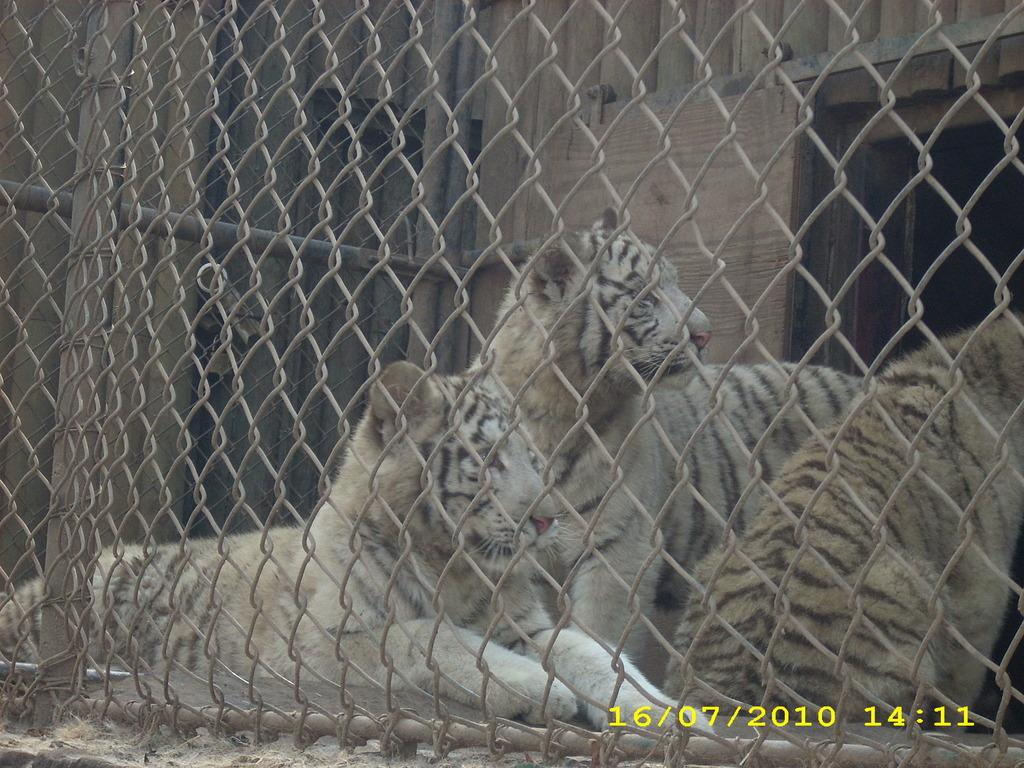What types of living organisms are present in the image? There are animals in the image. What is separating the animals from the viewer? There is fencing in front of the animals. What is located behind the animals? There is a wall behind the animals. What structures can be seen in the image besides the fencing and wall? There are poles visible in the image. What information is provided at the bottom of the image? There is text at the bottom of the image. How many children are playing in the hole near the animals in the image? There is no hole or children present in the image; it features animals with fencing and a wall in the background. 